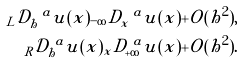Convert formula to latex. <formula><loc_0><loc_0><loc_500><loc_500>_ { L } \mathcal { D } ^ { \ a } _ { h } u ( x ) _ { - \infty } D ^ { \ a } _ { x } u ( x ) + O ( h ^ { 2 } ) , \\ _ { R } \mathcal { D } ^ { \ a } _ { h } u ( x ) _ { x } D ^ { \ a } _ { + \infty } u ( x ) + O ( h ^ { 2 } ) .</formula> 